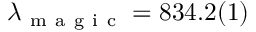<formula> <loc_0><loc_0><loc_500><loc_500>\lambda _ { m a g i c } = 8 3 4 . 2 ( 1 )</formula> 